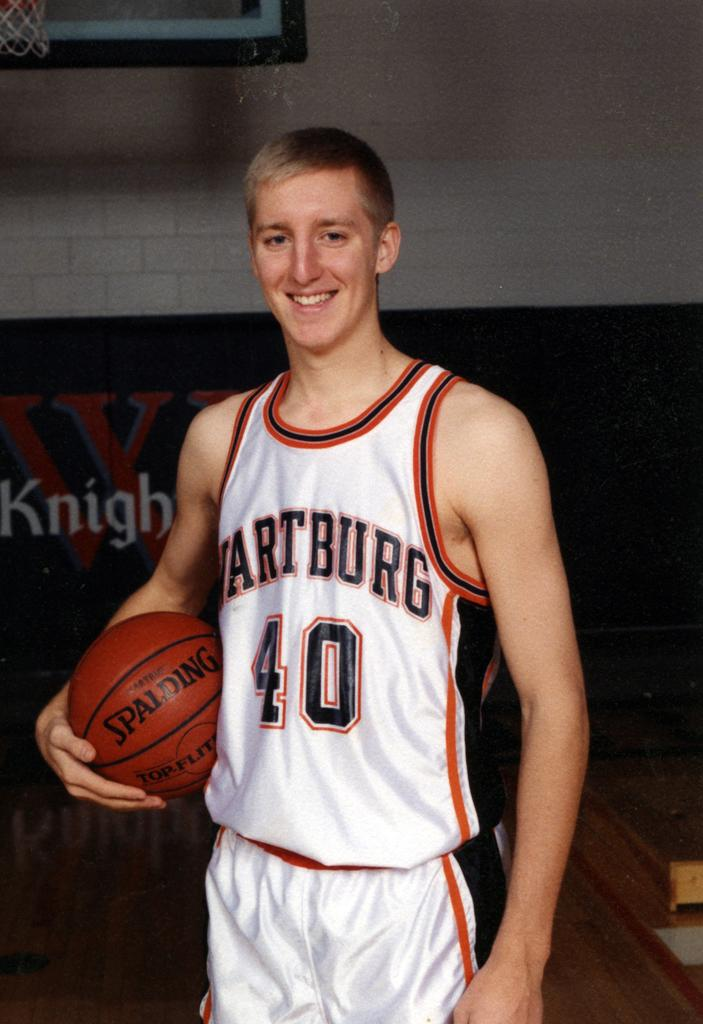<image>
Offer a succinct explanation of the picture presented. A basketball player holding a Spalding basketball in his hand. 